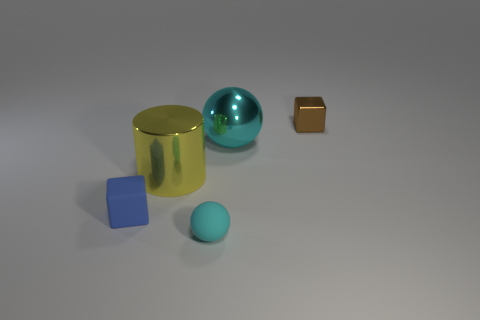Add 2 big purple spheres. How many objects exist? 7 Subtract 1 cyan spheres. How many objects are left? 4 Subtract all balls. How many objects are left? 3 Subtract all big cyan matte blocks. Subtract all large yellow metallic cylinders. How many objects are left? 4 Add 4 small matte objects. How many small matte objects are left? 6 Add 2 shiny balls. How many shiny balls exist? 3 